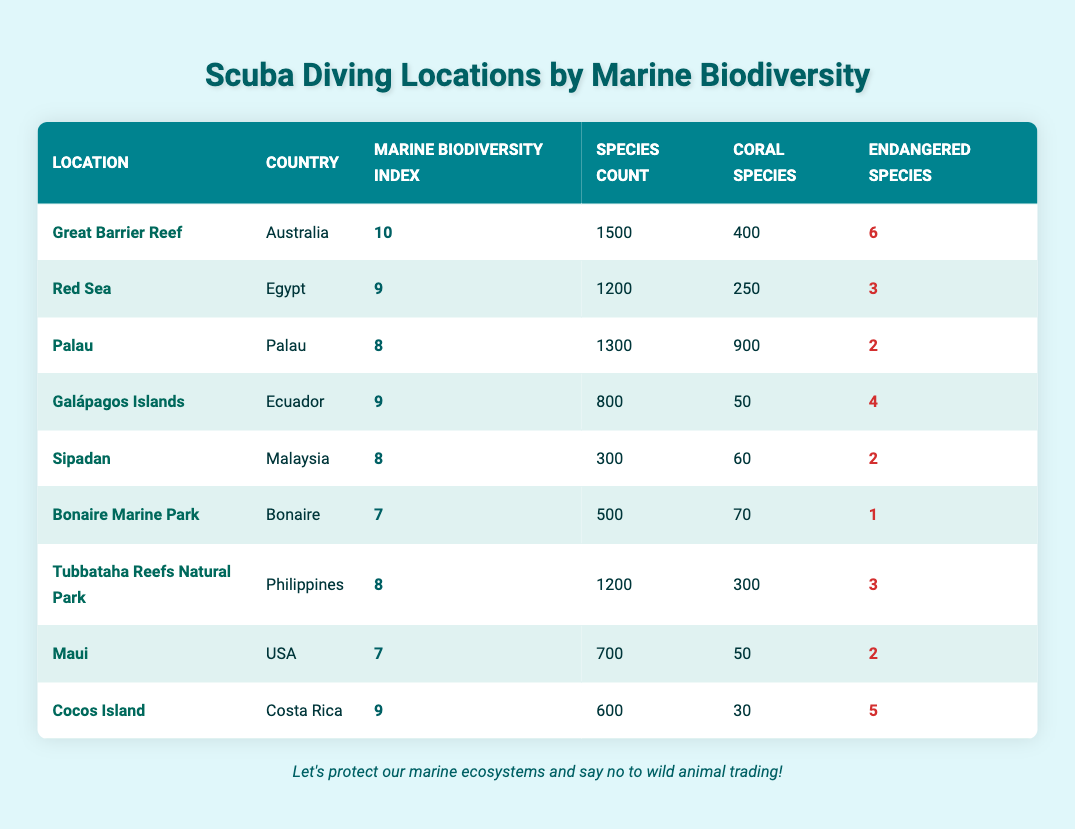What is the Marine Biodiversity Index of the Great Barrier Reef? The Marine Biodiversity Index of the Great Barrier Reef, as listed in the table, is found in the respective column for that location. It shows a value of 10.
Answer: 10 Which location has the highest species count? To answer this, I look through the Species Count column for all locations. The Great Barrier Reef has the highest count with 1500 species.
Answer: Great Barrier Reef How many locations have an Endangered Species count greater than 3? I review the Endangered Species column for each location. The Red Sea (3), Galápagos Islands (4), and Cocos Island (5) all have counts of 3 or more, totaling 3 locations.
Answer: 3 What is the average Marine Biodiversity Index for the locations listed? First, I sum the Marine Biodiversity Index values: (10 + 9 + 8 + 9 + 8 + 7 + 8 + 7 + 9) = 75. Since there are 9 locations, I calculate the average: 75/9 = 8.33 (rounded).
Answer: 8.33 Is it true that all locations have more than 200 species? I check the Species Count for each location. The only location with less than 200 is Sipadan, which has 300 species. Therefore, it is false that all locations have more than 200 species.
Answer: No What is the difference in Marine Biodiversity Index between the location with the highest index and the lowest? The highest index is from the Great Barrier Reef (10) and the lowest is Bonaire Marine Park (7). The difference is 10 - 7 = 3.
Answer: 3 How many coral species are found in the Galápagos Islands? Referring to the Coral Species column specifically for the Galápagos Islands, I find that there are 50 coral species listed.
Answer: 50 Which country has the second highest Marine Biodiversity Index? I look through the Marine Biodiversity Index column and note the second highest value. The Red Sea is 9, which is tied with Galápagos Islands. Since both are the second highest, the corresponding countries are Egypt and Ecuador.
Answer: Egypt, Ecuador Are there more coral species in Palau or Tubbataha Reefs Natural Park? Palau has 900 coral species while Tubbataha Reefs Natural Park has 300. By comparison, Palau has more coral species than Tubbataha.
Answer: Palau 